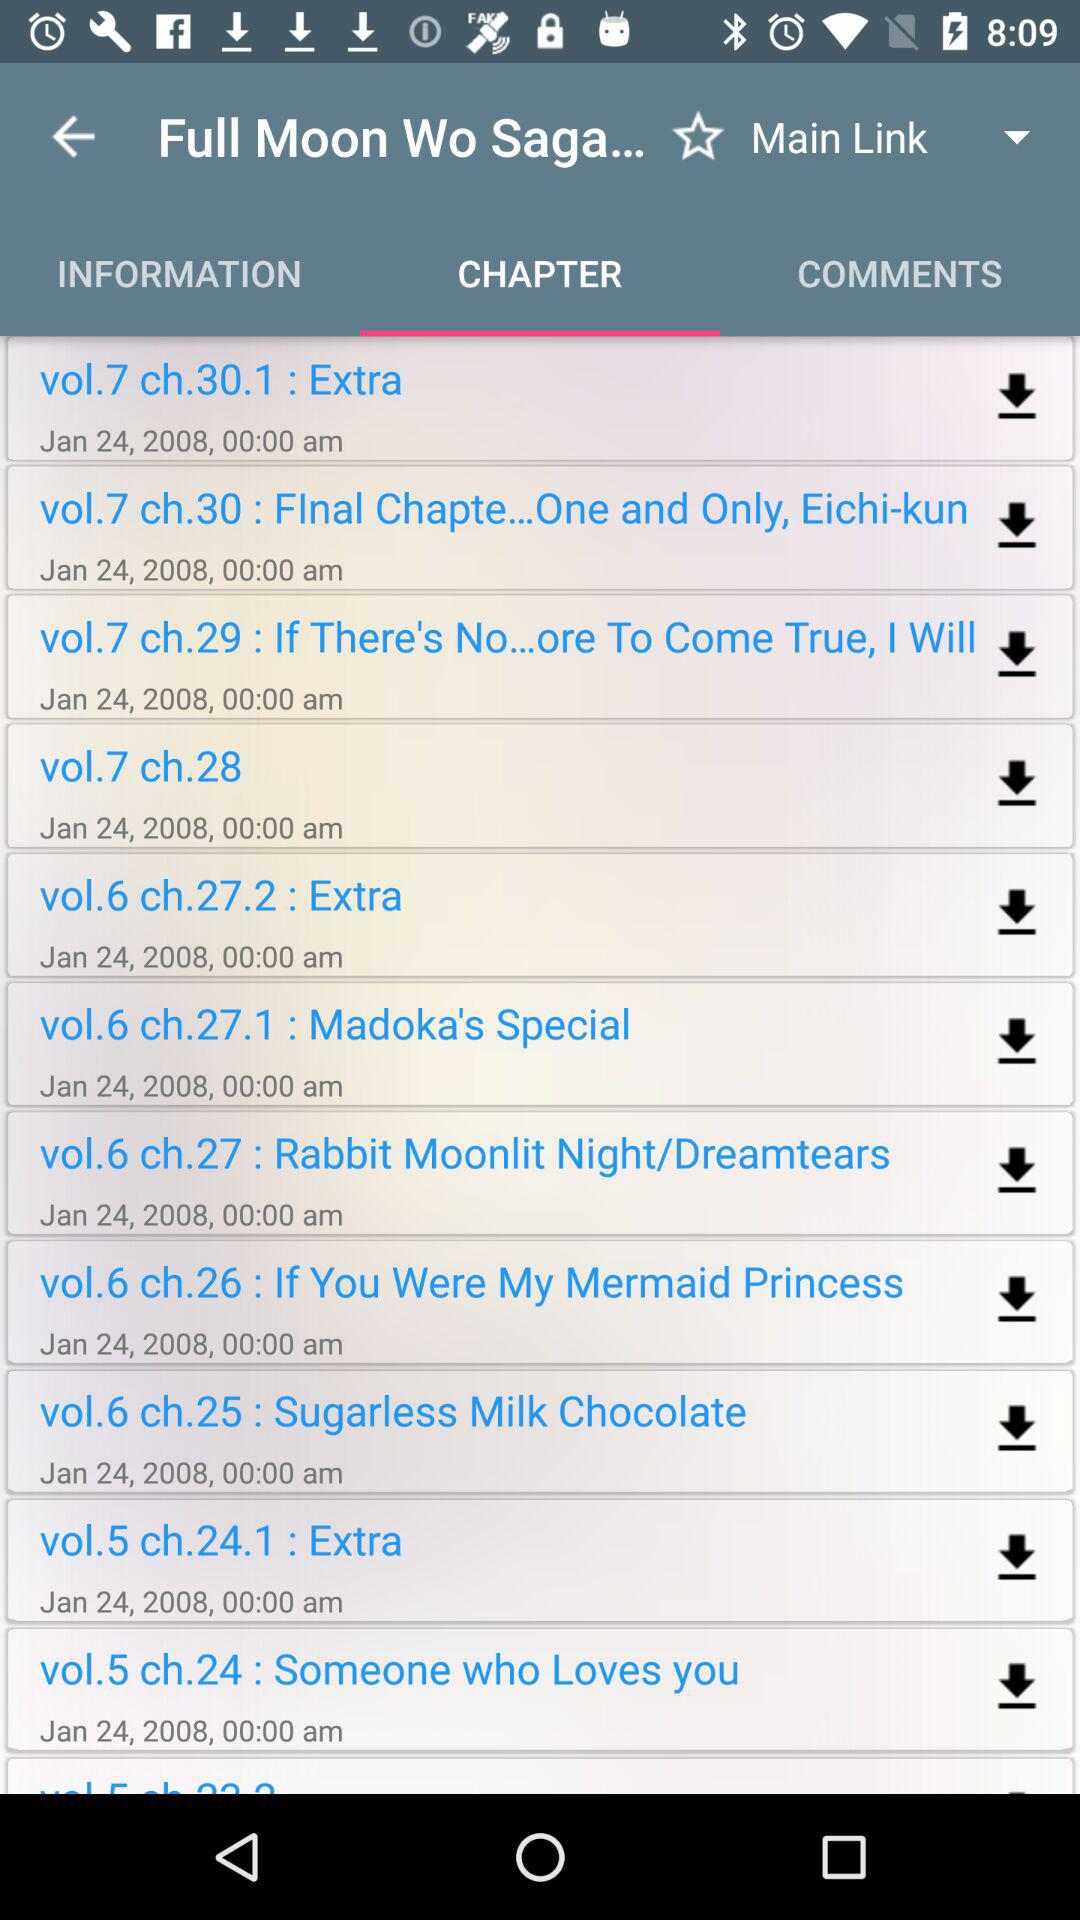When is the chapter "vol.6 ch.26 : If You Were My Mermaid Princess" to be uploaded? The chapter "vol.6 ch.26 : If You Were My Mermaid Princess" is to be uploaded on January 24, 2008, at 00:00 am. 